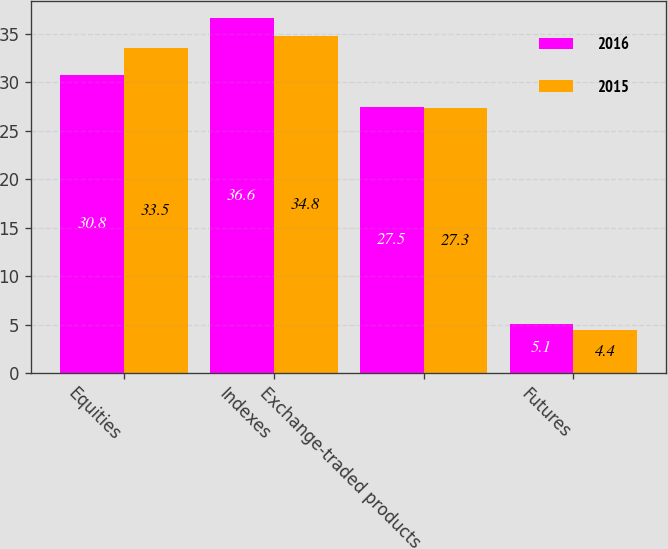Convert chart to OTSL. <chart><loc_0><loc_0><loc_500><loc_500><stacked_bar_chart><ecel><fcel>Equities<fcel>Indexes<fcel>Exchange-traded products<fcel>Futures<nl><fcel>2016<fcel>30.8<fcel>36.6<fcel>27.5<fcel>5.1<nl><fcel>2015<fcel>33.5<fcel>34.8<fcel>27.3<fcel>4.4<nl></chart> 